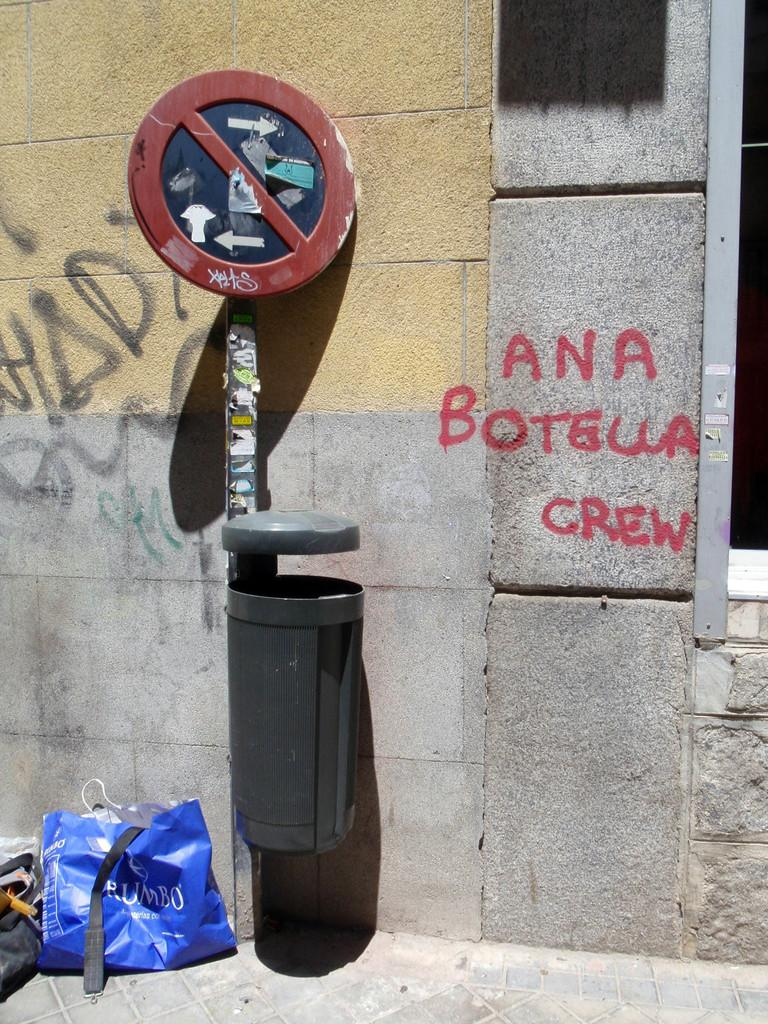Provide a one-sentence caption for the provided image. a little bin next to some graffiti, some of which reads Ana Botella Crew. 